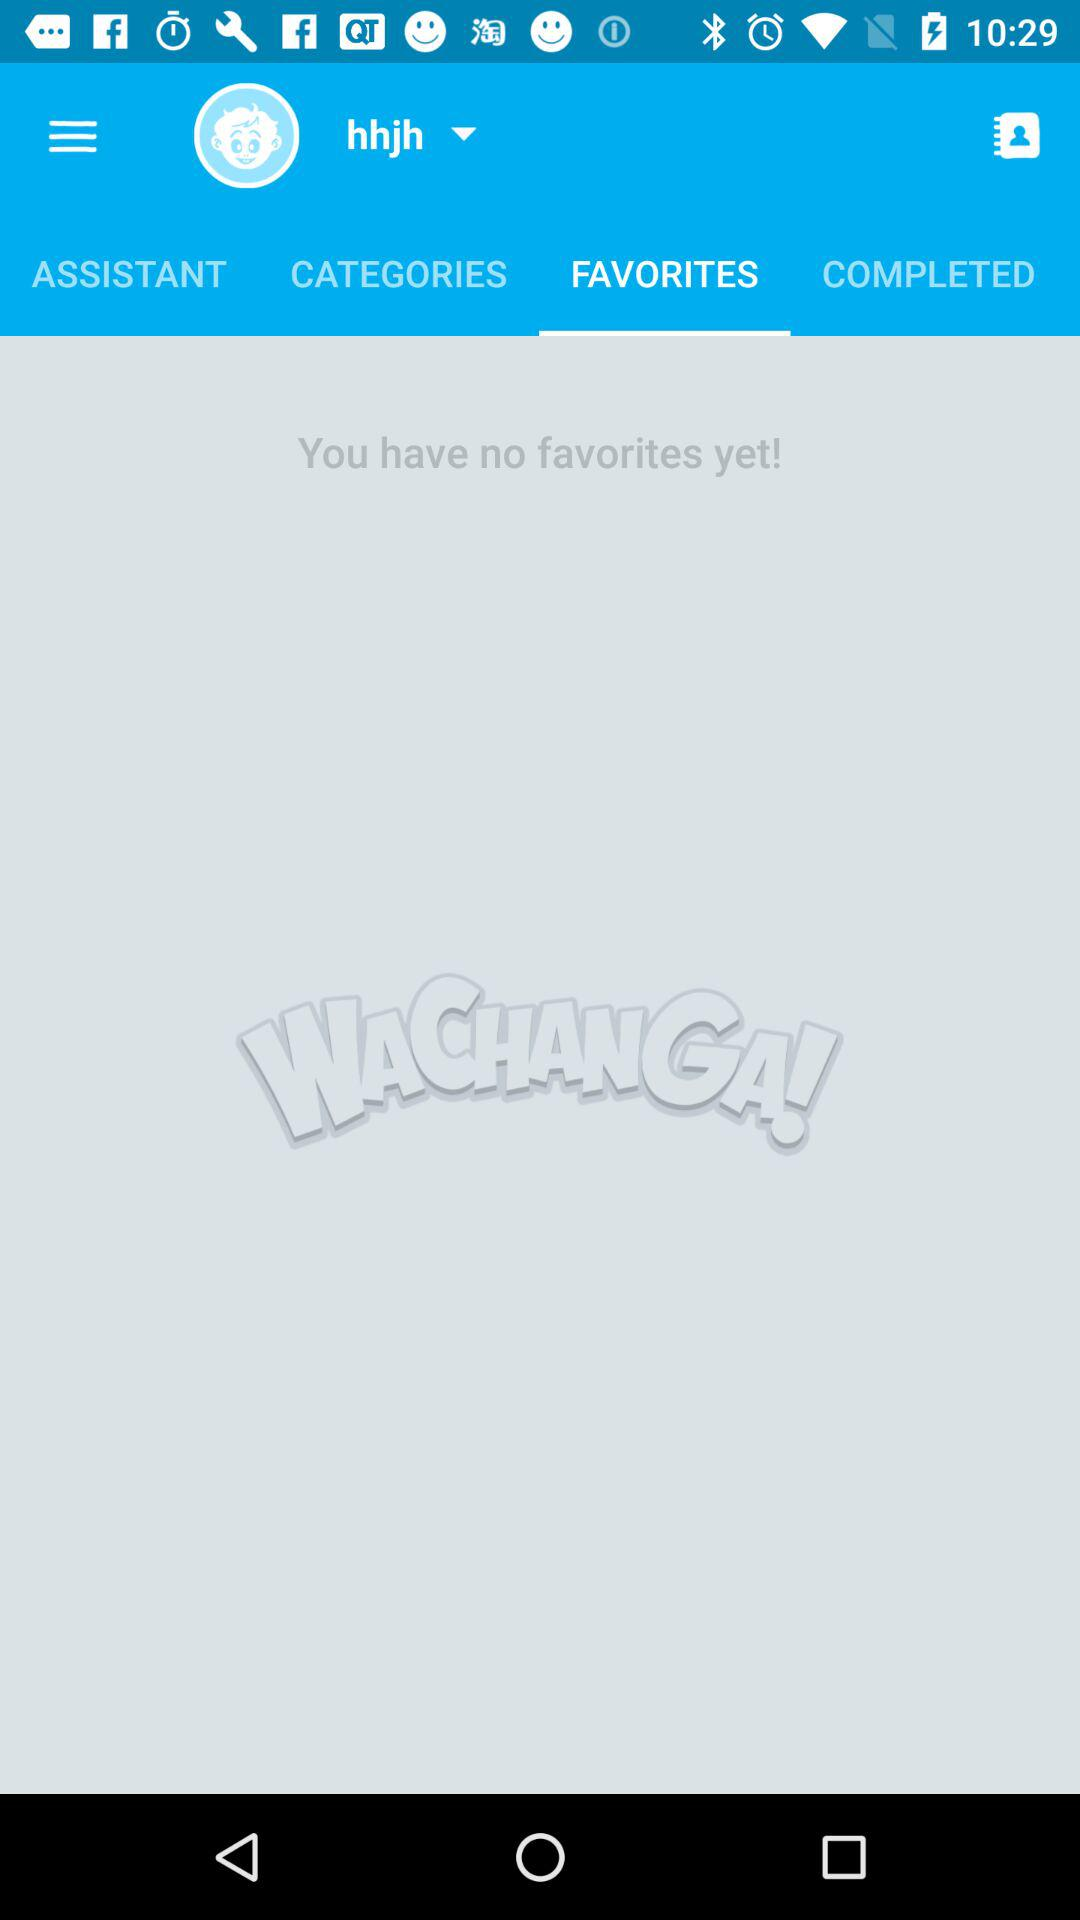Which tab is selected? The selected tab is "FAVORITES". 